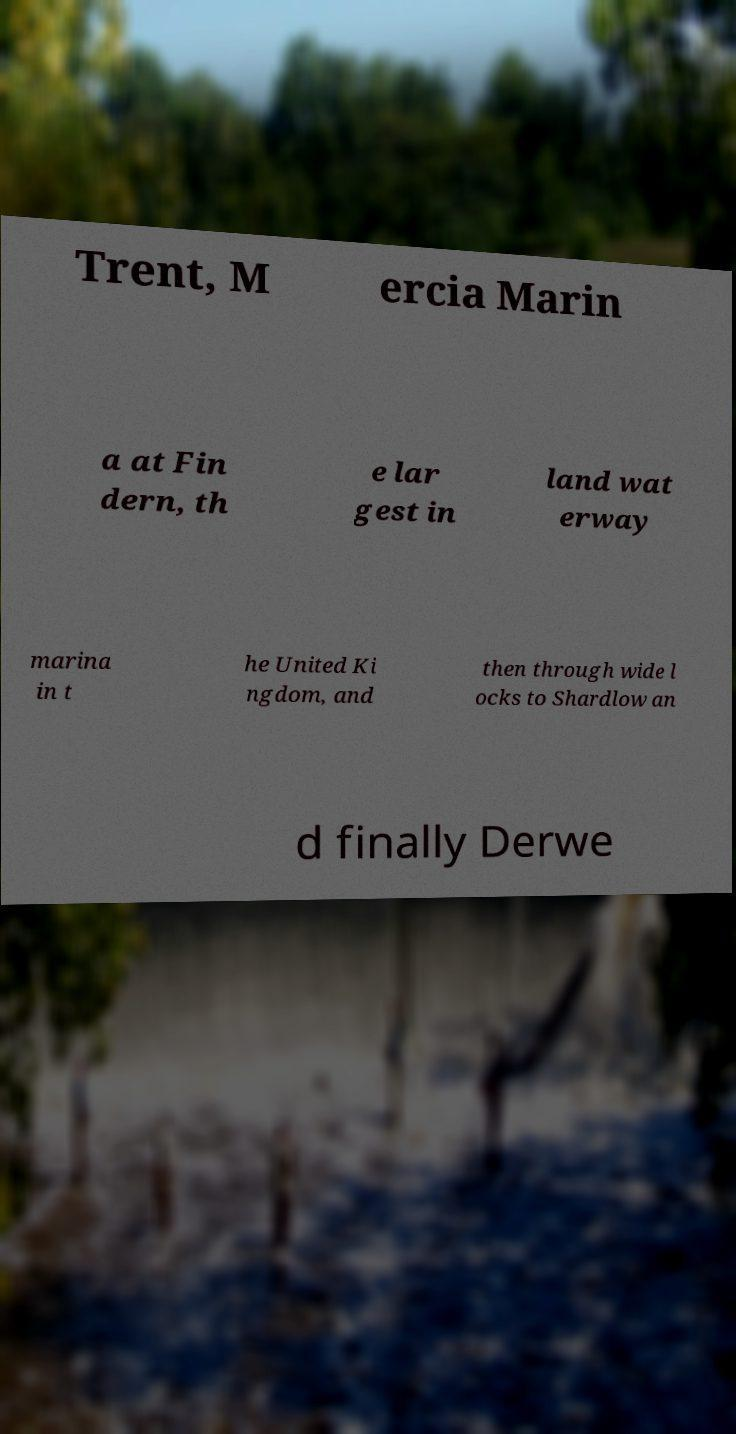Could you extract and type out the text from this image? Trent, M ercia Marin a at Fin dern, th e lar gest in land wat erway marina in t he United Ki ngdom, and then through wide l ocks to Shardlow an d finally Derwe 